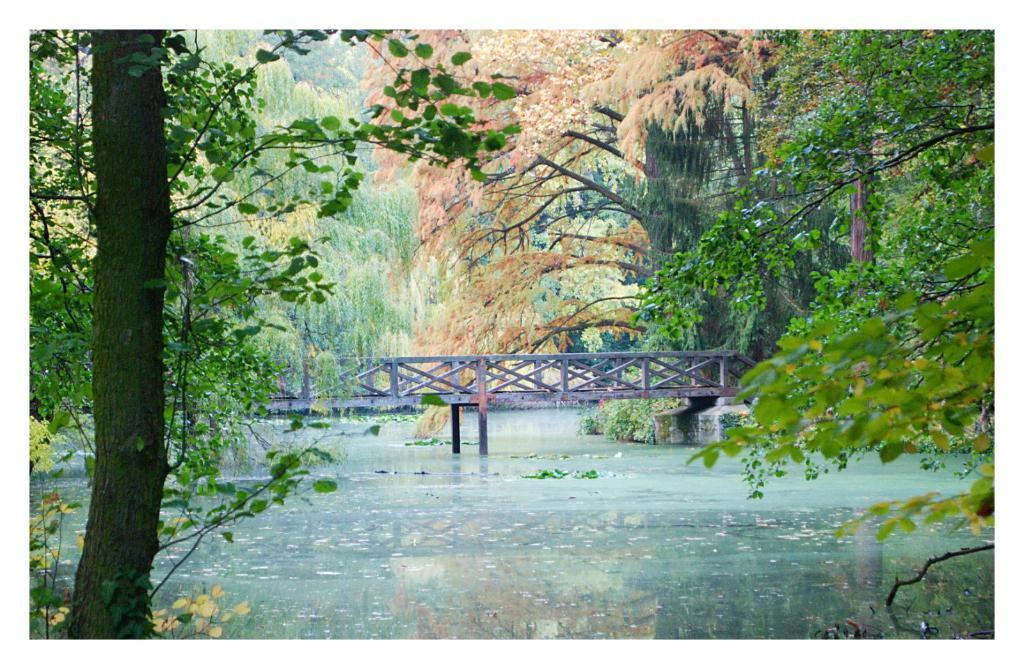Could you give a brief overview of what you see in this image? In this picture we can see a bridge across the water and behind the bridge there are trees. 